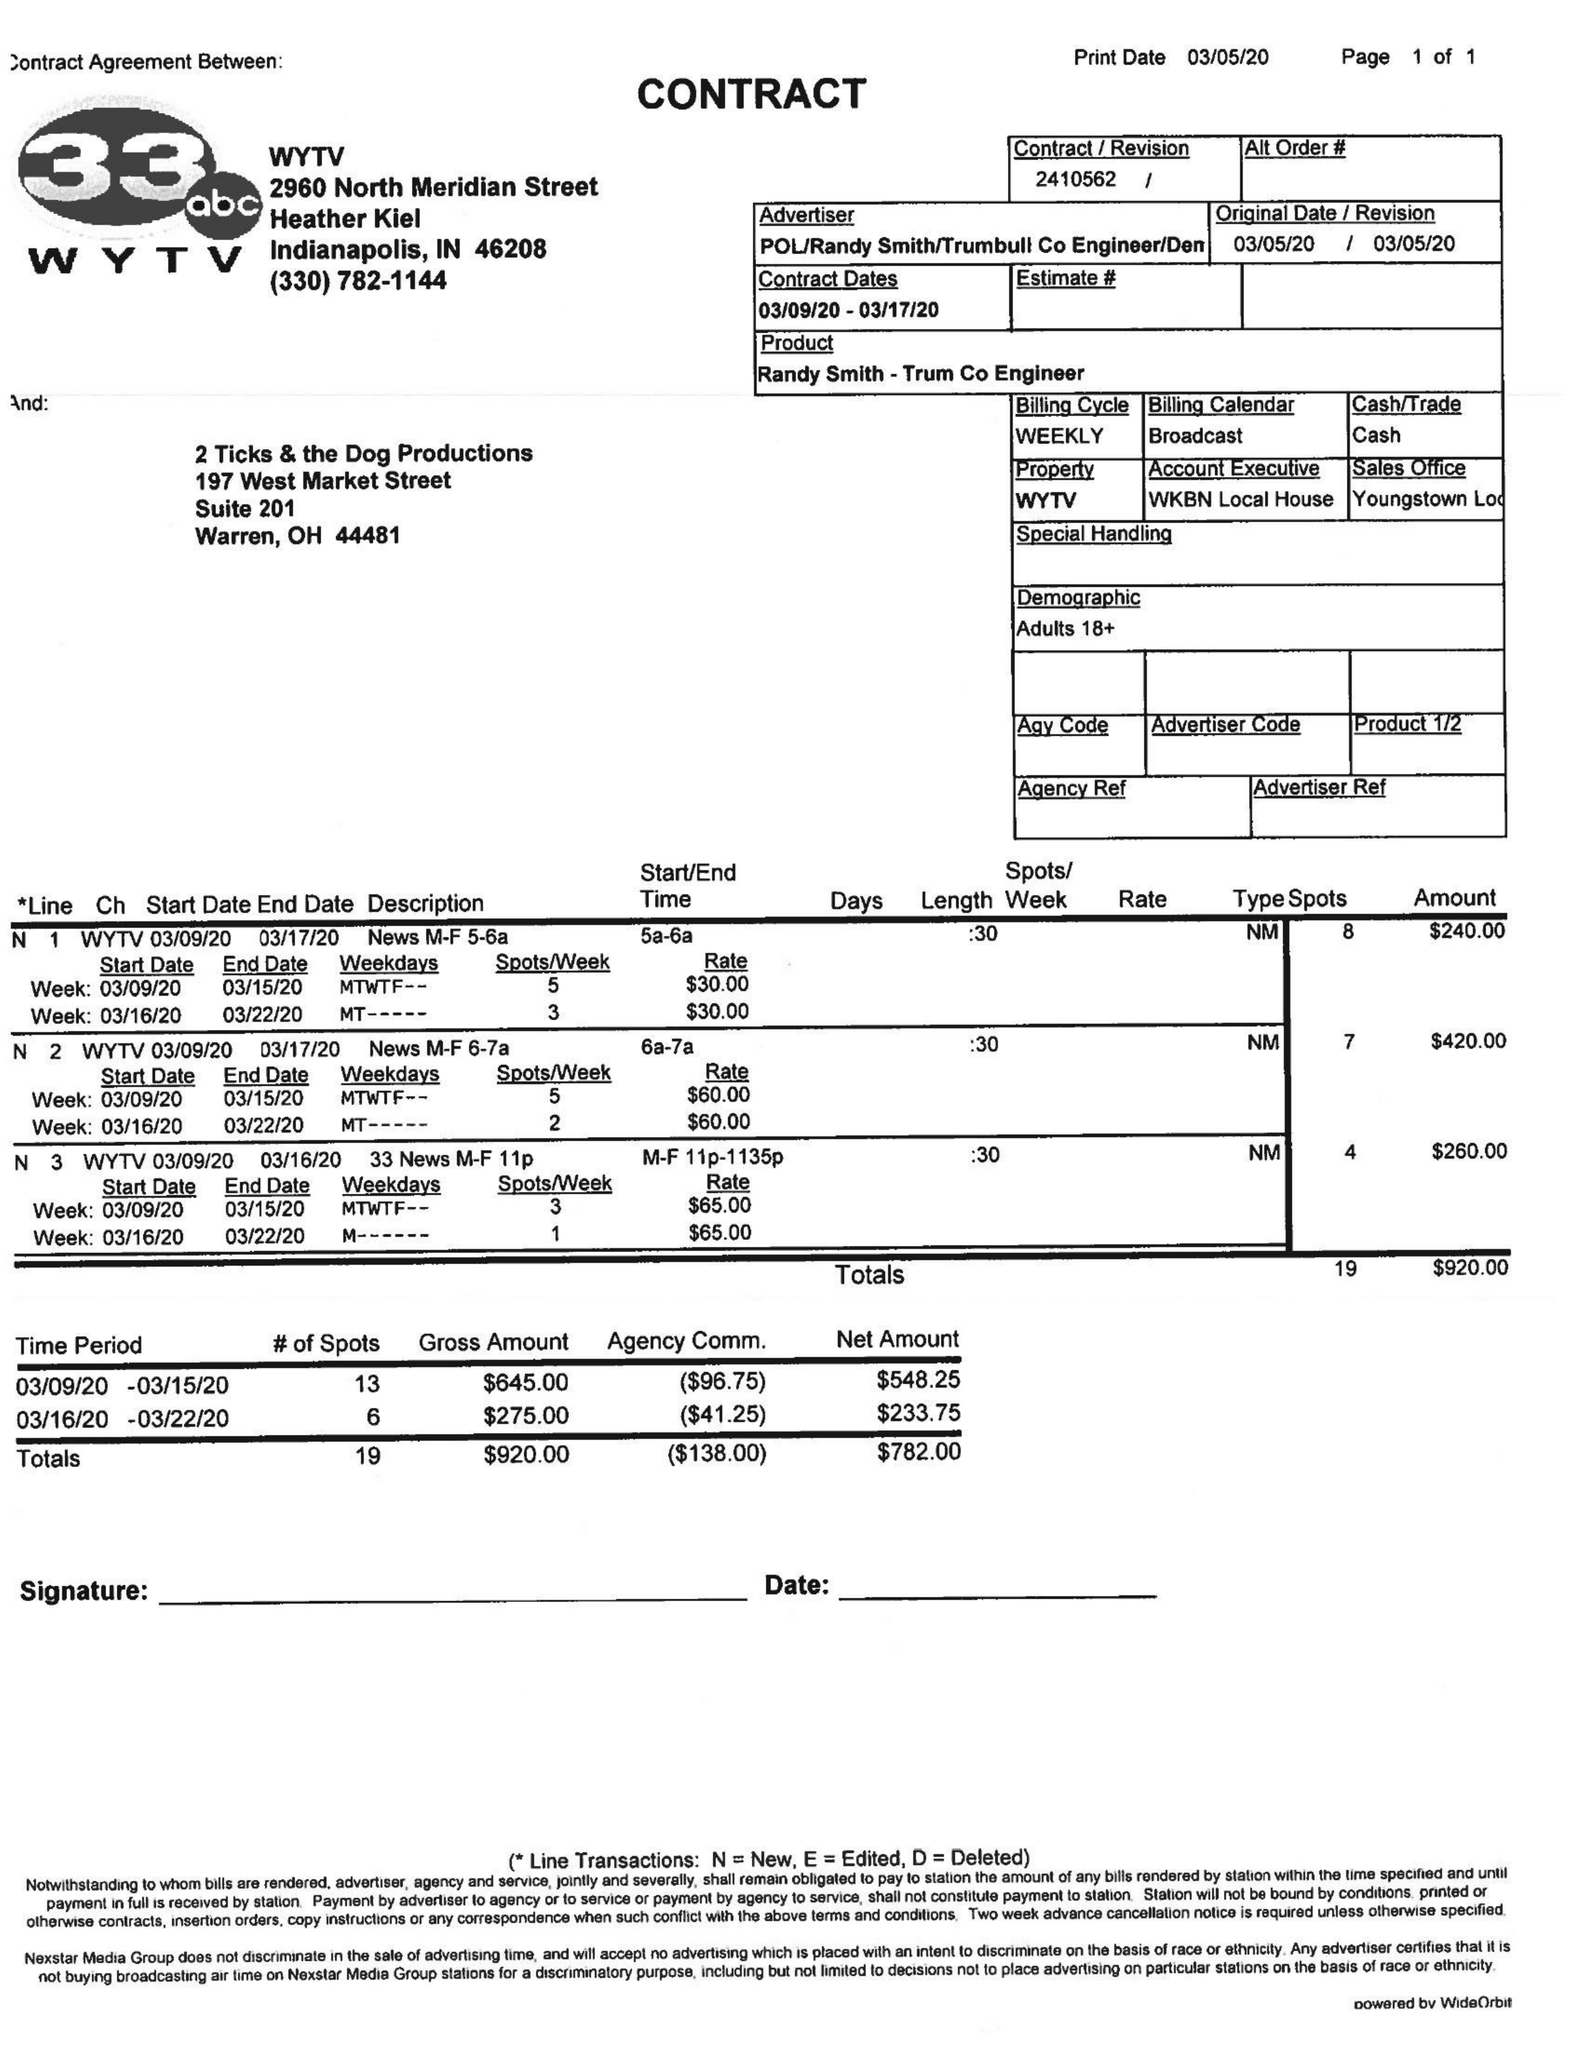What is the value for the gross_amount?
Answer the question using a single word or phrase. 920.00 